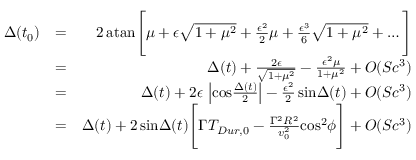<formula> <loc_0><loc_0><loc_500><loc_500>\begin{array} { r l r } { \Delta ( t _ { 0 } ) } & { = } & { 2 \, a t a n \left [ \mu + \epsilon \sqrt { 1 + \mu ^ { 2 } } + { \frac { \epsilon ^ { 2 } } { 2 } } \mu + { \frac { \epsilon ^ { 3 } } { 6 } } \sqrt { 1 + \mu ^ { 2 } } + \dots \right ] } \\ & { = } & { \Delta ( t ) + { \frac { 2 \epsilon } { \sqrt { 1 + \mu ^ { 2 } } } } - { \frac { \epsilon ^ { 2 } \mu } { 1 + \mu ^ { 2 } } } + O ( S c ^ { 3 } ) } \\ & { = } & { \Delta ( t ) + 2 \epsilon \, \left | \cos { \frac { \Delta ( t ) } { 2 } } \right | - { \frac { \epsilon ^ { 2 } } { 2 } } \, \sin \Delta ( t ) + O ( S c ^ { 3 } ) } \\ & { = } & { \Delta ( t ) + 2 \, \sin \Delta ( t ) \left [ \Gamma T _ { D u r , 0 } - { \frac { \Gamma ^ { 2 } R ^ { 2 } } { v _ { 0 } ^ { 2 } } } \cos ^ { 2 } \phi \right ] + O ( S c ^ { 3 } ) } \end{array}</formula> 